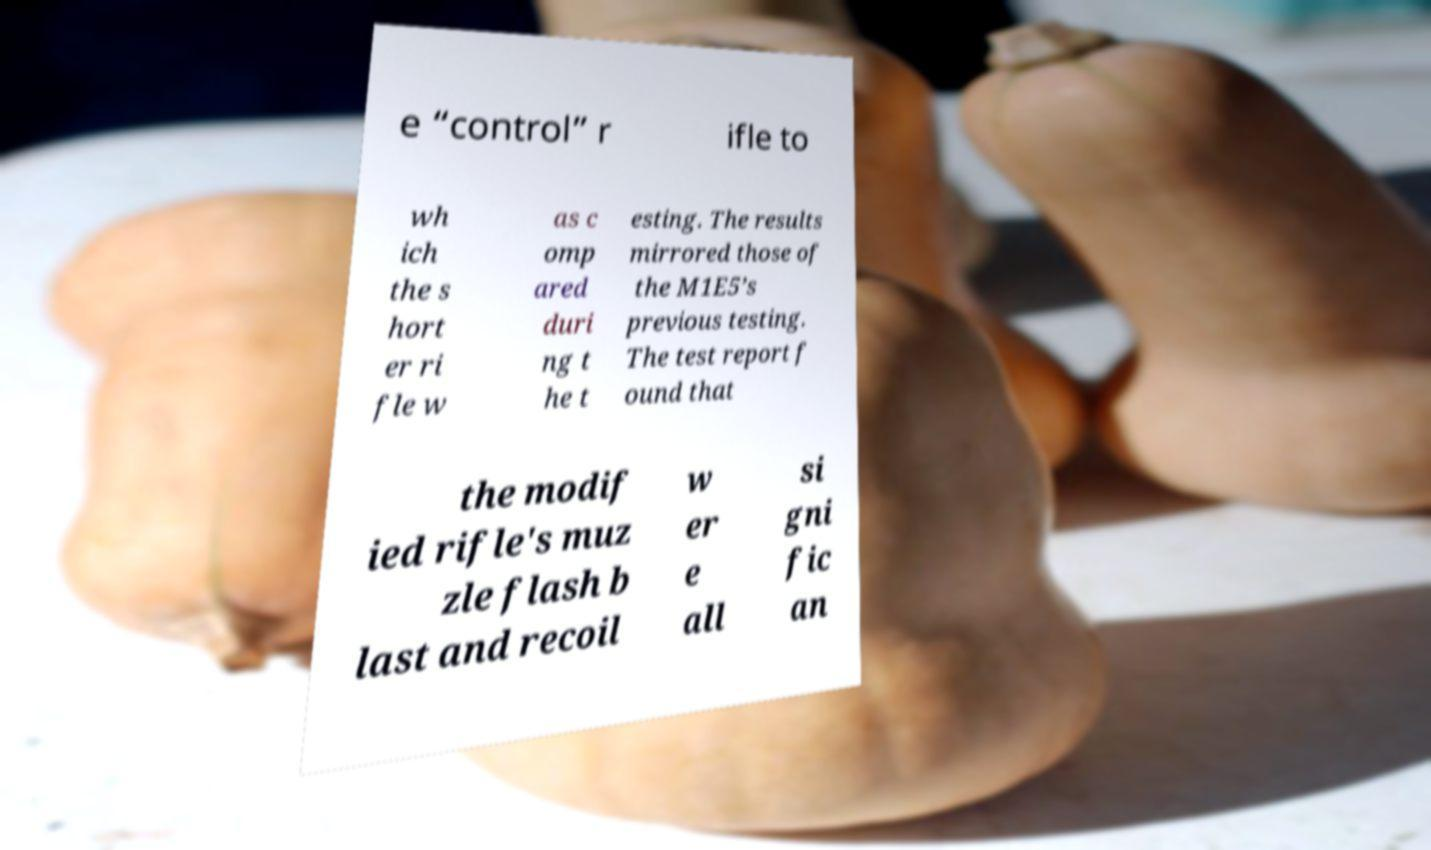Could you extract and type out the text from this image? e “control” r ifle to wh ich the s hort er ri fle w as c omp ared duri ng t he t esting. The results mirrored those of the M1E5’s previous testing. The test report f ound that the modif ied rifle's muz zle flash b last and recoil w er e all si gni fic an 